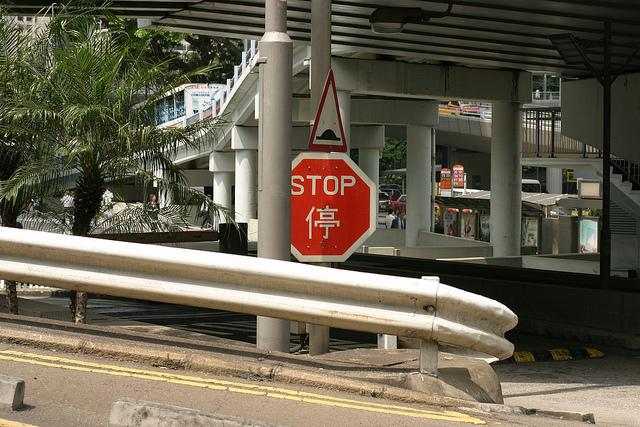What device is used to ensure people stop here? stop sign 